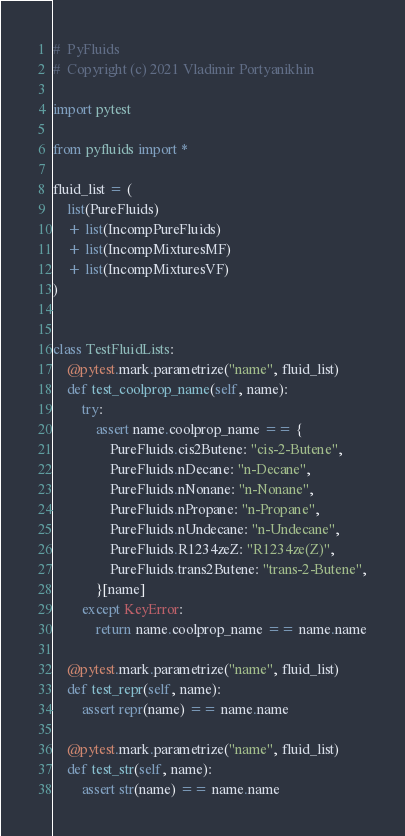<code> <loc_0><loc_0><loc_500><loc_500><_Python_>#  PyFluids
#  Copyright (c) 2021 Vladimir Portyanikhin

import pytest

from pyfluids import *

fluid_list = (
    list(PureFluids)
    + list(IncompPureFluids)
    + list(IncompMixturesMF)
    + list(IncompMixturesVF)
)


class TestFluidLists:
    @pytest.mark.parametrize("name", fluid_list)
    def test_coolprop_name(self, name):
        try:
            assert name.coolprop_name == {
                PureFluids.cis2Butene: "cis-2-Butene",
                PureFluids.nDecane: "n-Decane",
                PureFluids.nNonane: "n-Nonane",
                PureFluids.nPropane: "n-Propane",
                PureFluids.nUndecane: "n-Undecane",
                PureFluids.R1234zeZ: "R1234ze(Z)",
                PureFluids.trans2Butene: "trans-2-Butene",
            }[name]
        except KeyError:
            return name.coolprop_name == name.name

    @pytest.mark.parametrize("name", fluid_list)
    def test_repr(self, name):
        assert repr(name) == name.name

    @pytest.mark.parametrize("name", fluid_list)
    def test_str(self, name):
        assert str(name) == name.name
</code> 